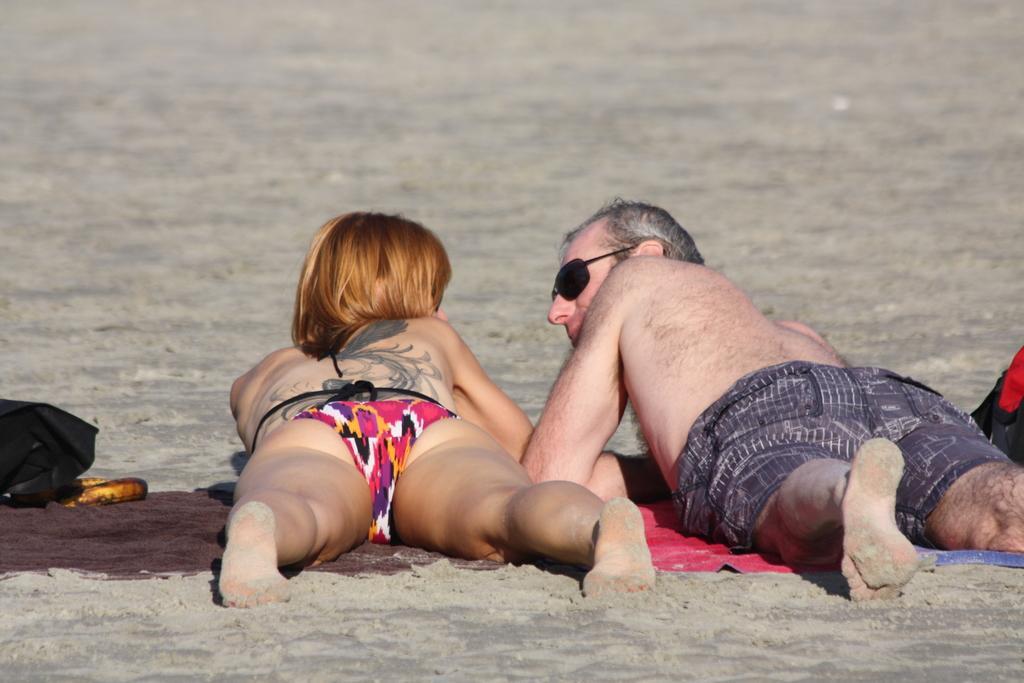How would you summarize this image in a sentence or two? In this picture, there is a woman and a man lying on the cloth which is placed on the ground. Both of them are facing backwards. Towards the left, there is a bag. 